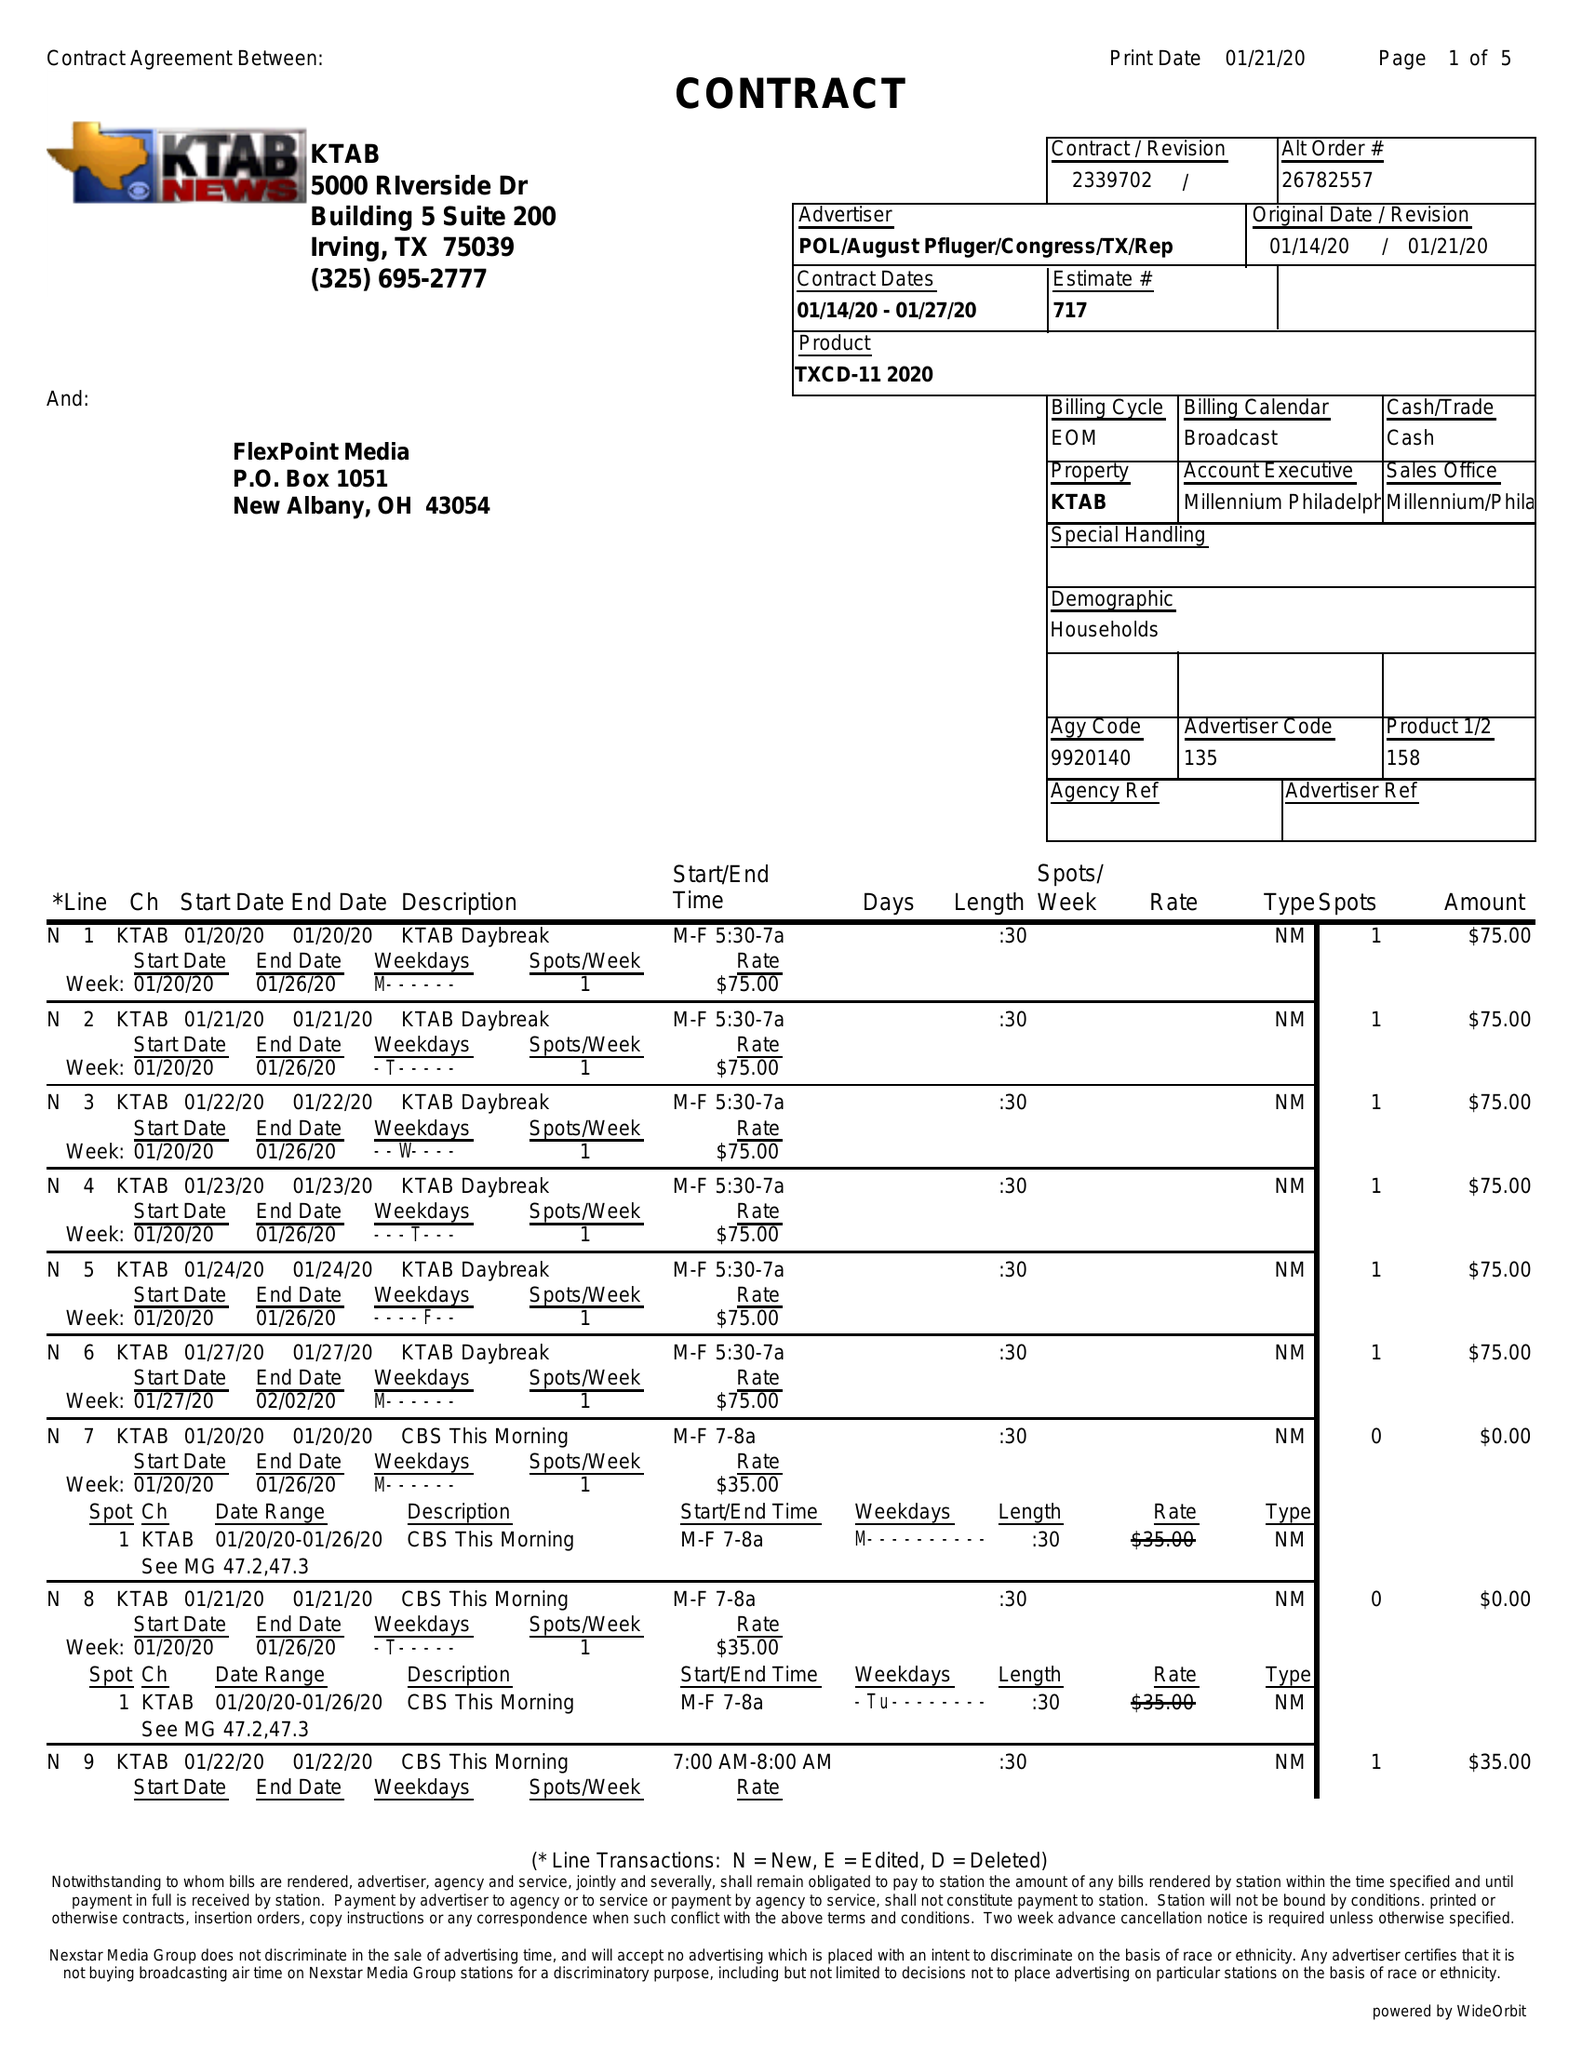What is the value for the flight_from?
Answer the question using a single word or phrase. 01/14/20 